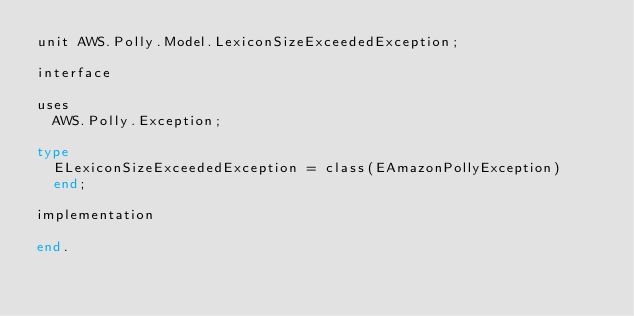Convert code to text. <code><loc_0><loc_0><loc_500><loc_500><_Pascal_>unit AWS.Polly.Model.LexiconSizeExceededException;

interface

uses
  AWS.Polly.Exception;

type
  ELexiconSizeExceededException = class(EAmazonPollyException)
  end;
  
implementation

end.
</code> 